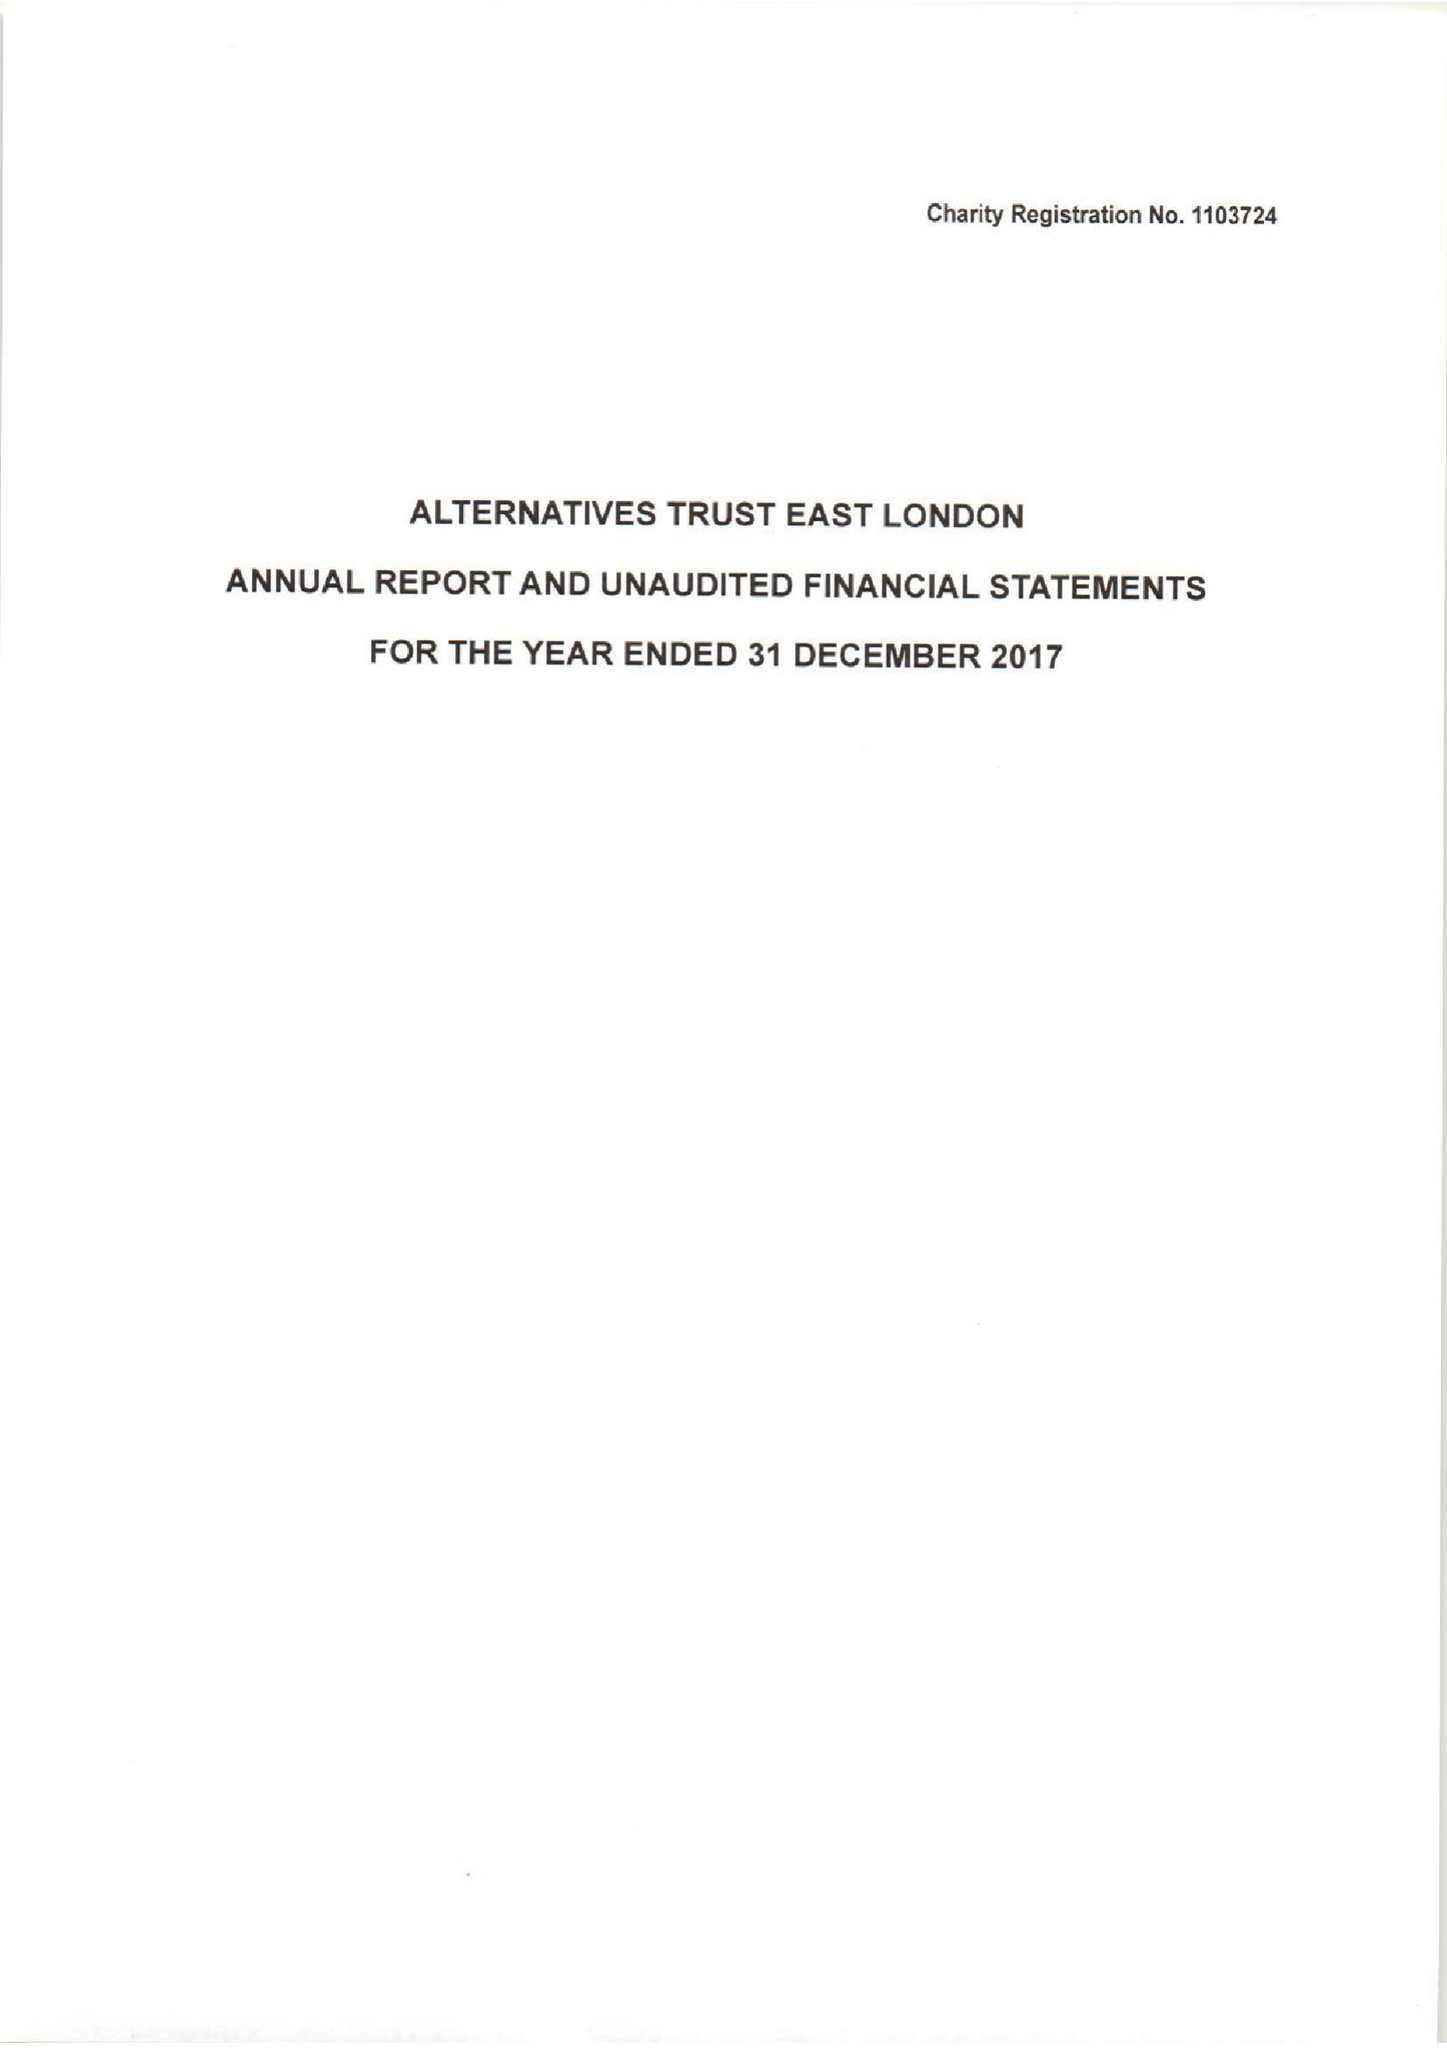What is the value for the charity_number?
Answer the question using a single word or phrase. 1103724 